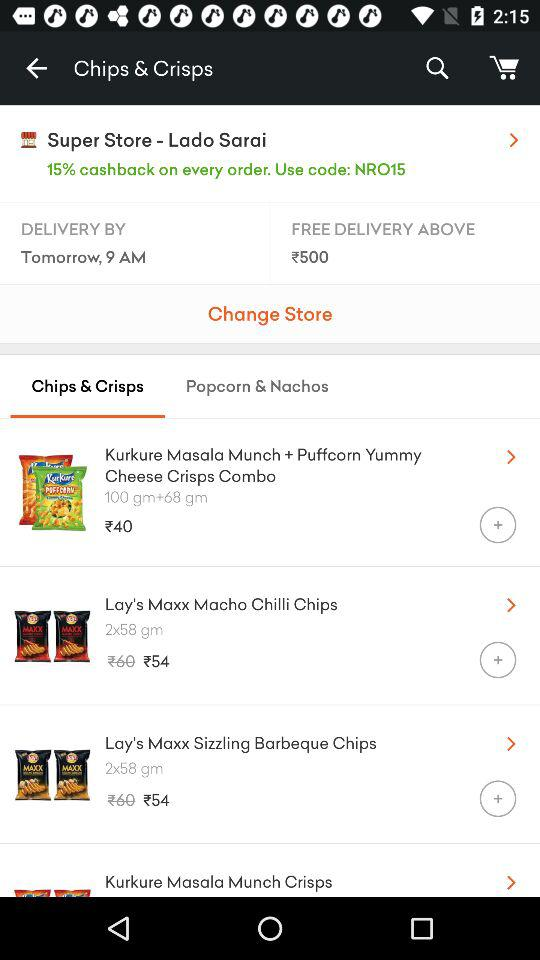What is the weight of Lay's Maxx Macho Chilli Chips? The weight is "2x58 gm". 